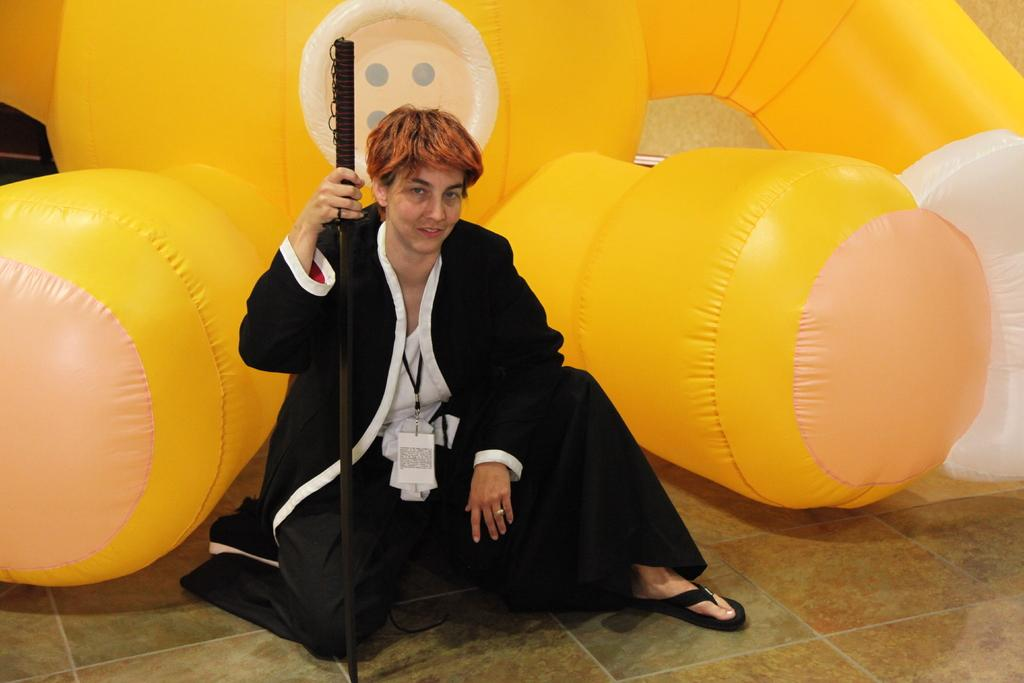What is the main subject of the image? There is a person in the image. What is the person doing in the image? The person is smiling. What object is the person holding in the image? The person is holding a stick. What can be seen in the background of the image? There is an inflatable bounce house in the background of the image. What type of dress is the person wearing in the image? The provided facts do not mention any dress or clothing worn by the person in the image. 